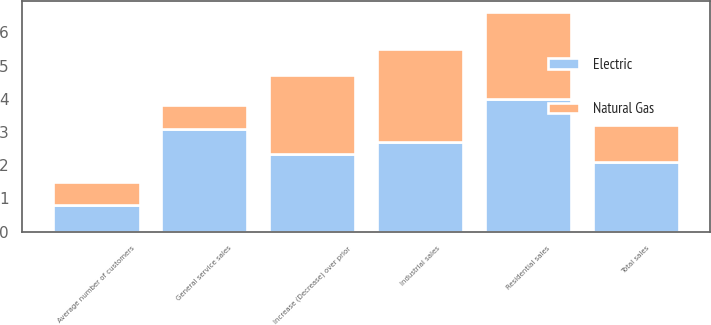Convert chart to OTSL. <chart><loc_0><loc_0><loc_500><loc_500><stacked_bar_chart><ecel><fcel>Increase (Decrease) over prior<fcel>Residential sales<fcel>General service sales<fcel>Industrial sales<fcel>Total sales<fcel>Average number of customers<nl><fcel>Electric<fcel>2.35<fcel>4<fcel>3.1<fcel>2.7<fcel>2.1<fcel>0.8<nl><fcel>Natural Gas<fcel>2.35<fcel>2.6<fcel>0.7<fcel>2.8<fcel>1.1<fcel>0.7<nl></chart> 